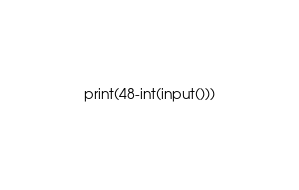Convert code to text. <code><loc_0><loc_0><loc_500><loc_500><_Python_>print(48-int(input()))</code> 